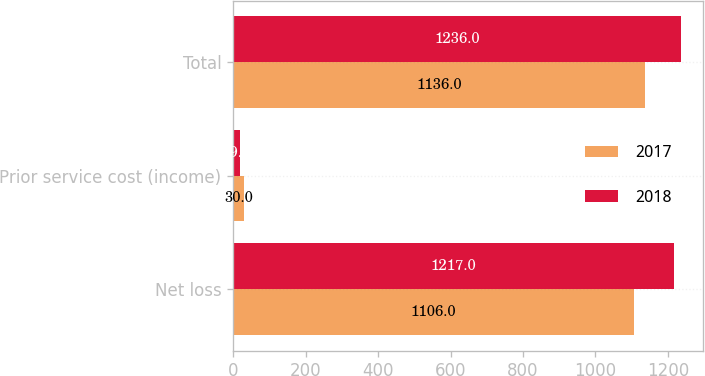Convert chart to OTSL. <chart><loc_0><loc_0><loc_500><loc_500><stacked_bar_chart><ecel><fcel>Net loss<fcel>Prior service cost (income)<fcel>Total<nl><fcel>2017<fcel>1106<fcel>30<fcel>1136<nl><fcel>2018<fcel>1217<fcel>19<fcel>1236<nl></chart> 